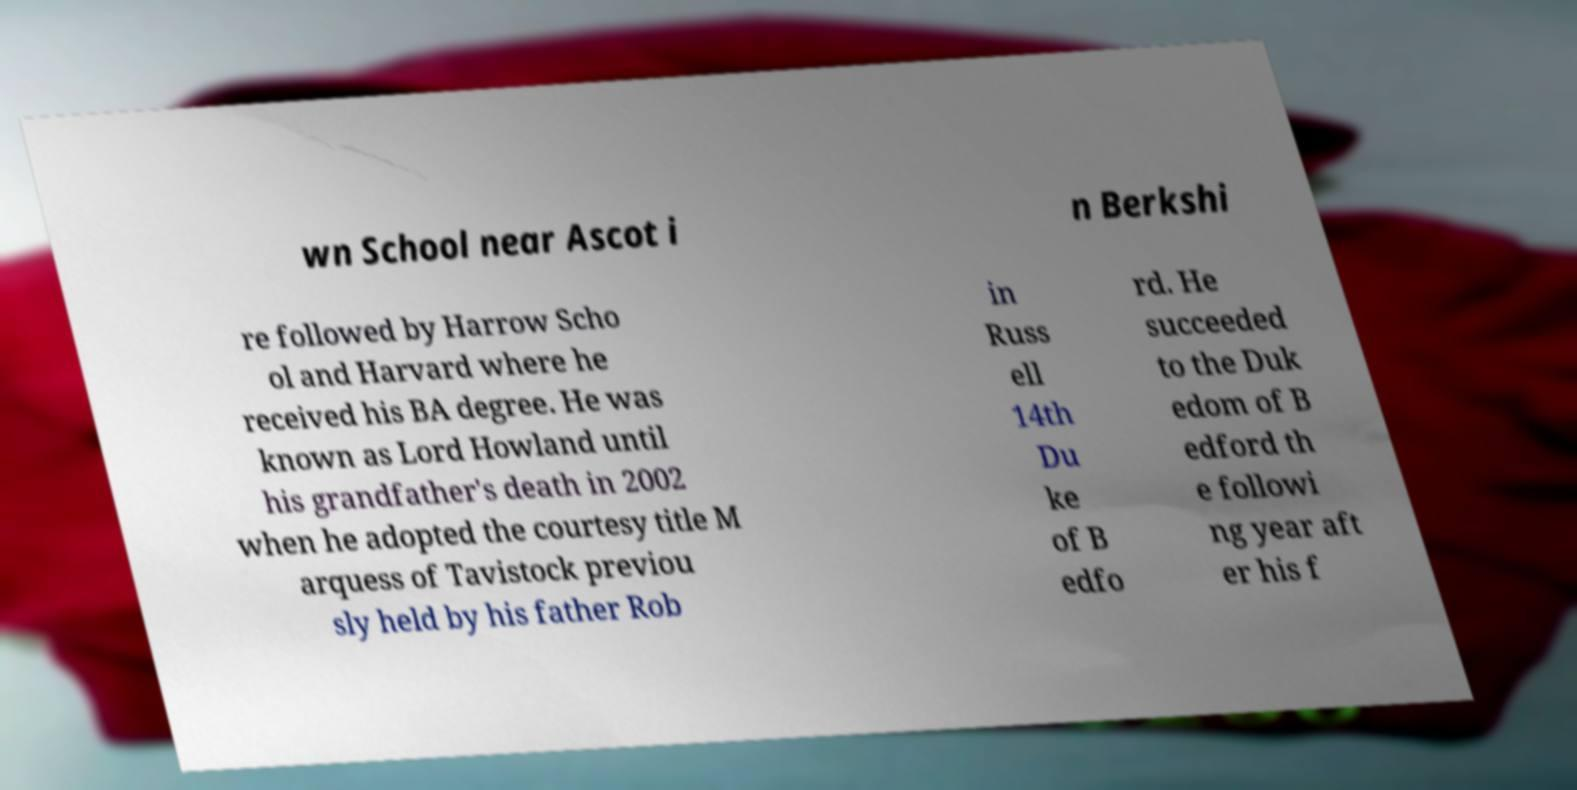Please read and relay the text visible in this image. What does it say? wn School near Ascot i n Berkshi re followed by Harrow Scho ol and Harvard where he received his BA degree. He was known as Lord Howland until his grandfather's death in 2002 when he adopted the courtesy title M arquess of Tavistock previou sly held by his father Rob in Russ ell 14th Du ke of B edfo rd. He succeeded to the Duk edom of B edford th e followi ng year aft er his f 